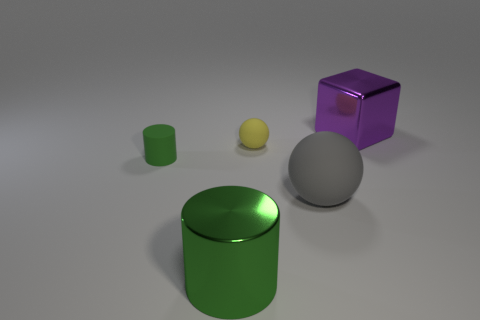The matte thing left of the large green metal object has what shape?
Ensure brevity in your answer.  Cylinder. Are there any other cylinders of the same color as the matte cylinder?
Give a very brief answer. Yes. Does the thing on the right side of the large gray rubber sphere have the same size as the metallic object that is in front of the big purple block?
Your answer should be compact. Yes. Is the number of things left of the cube greater than the number of tiny yellow matte spheres that are on the right side of the small yellow rubber object?
Make the answer very short. Yes. Is there a large cyan block made of the same material as the gray sphere?
Make the answer very short. No. Is the color of the big block the same as the tiny cylinder?
Provide a short and direct response. No. The object that is to the left of the large gray object and in front of the small green thing is made of what material?
Offer a very short reply. Metal. What is the color of the big sphere?
Offer a very short reply. Gray. How many tiny things are the same shape as the big green metal object?
Offer a terse response. 1. Does the ball that is in front of the small yellow object have the same material as the green cylinder that is to the right of the tiny rubber cylinder?
Your answer should be compact. No. 